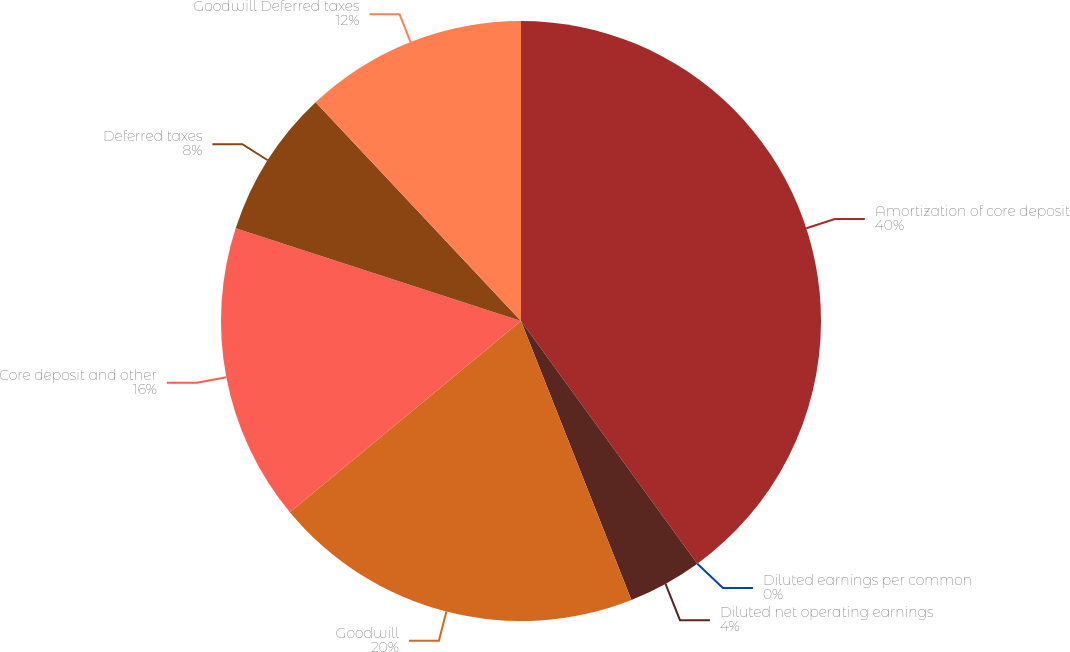<chart> <loc_0><loc_0><loc_500><loc_500><pie_chart><fcel>Amortization of core deposit<fcel>Diluted earnings per common<fcel>Diluted net operating earnings<fcel>Goodwill<fcel>Core deposit and other<fcel>Deferred taxes<fcel>Goodwill Deferred taxes<nl><fcel>40.0%<fcel>0.0%<fcel>4.0%<fcel>20.0%<fcel>16.0%<fcel>8.0%<fcel>12.0%<nl></chart> 